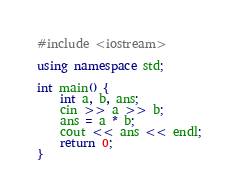<code> <loc_0><loc_0><loc_500><loc_500><_C++_>#include <iostream>

using namespace std;

int main() {
	int a, b, ans;
	cin >> a >> b;
	ans = a * b;
	cout << ans << endl;
    return 0;
}</code> 